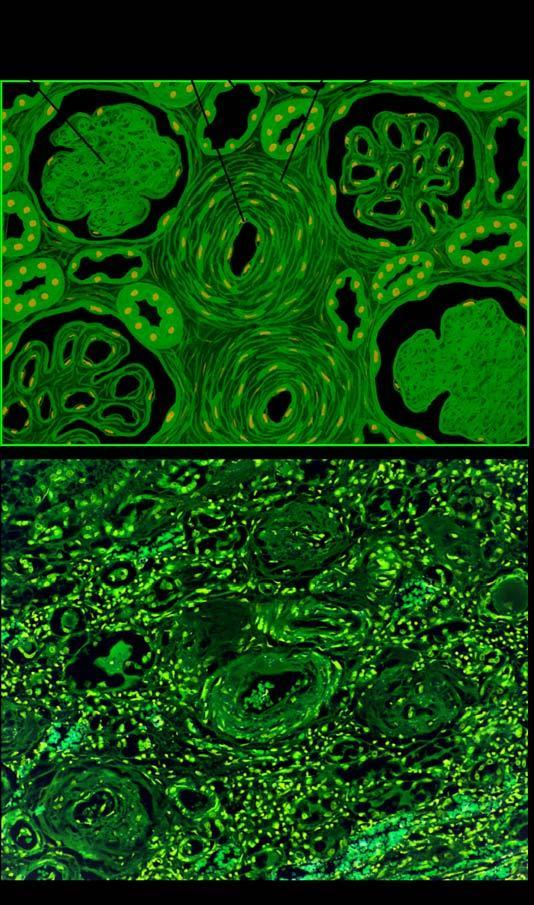what are the vascular changes?
Answer the question using a single word or phrase. Hyaline arteriolosclerosis and intimal thickening of small blood vessels in the glomerular tuft 